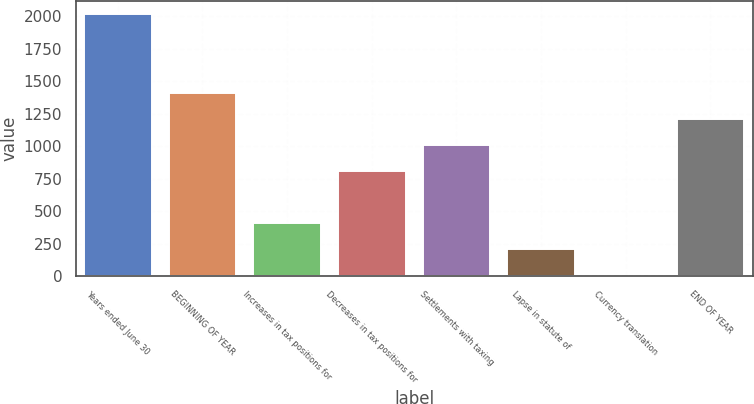<chart> <loc_0><loc_0><loc_500><loc_500><bar_chart><fcel>Years ended June 30<fcel>BEGINNING OF YEAR<fcel>Increases in tax positions for<fcel>Decreases in tax positions for<fcel>Settlements with taxing<fcel>Lapse in statute of<fcel>Currency translation<fcel>END OF YEAR<nl><fcel>2017<fcel>1413.1<fcel>406.6<fcel>809.2<fcel>1010.5<fcel>205.3<fcel>4<fcel>1211.8<nl></chart> 